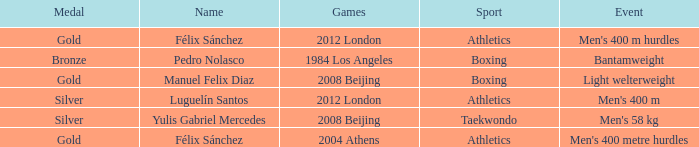Which Games had a Name of manuel felix diaz? 2008 Beijing. 